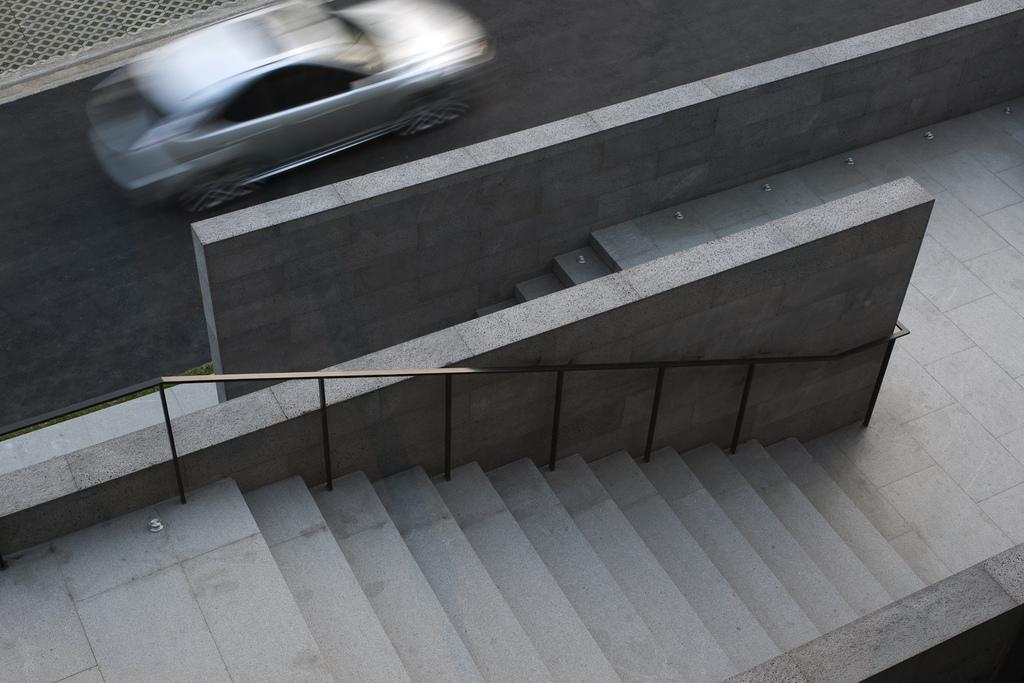What is on the road in the image? There is a vehicle on the road in the image. What can be seen beside the road? There is a wall beside the road. What is present in the image that might be used for support or safety? There is a railing in the image. What architectural feature can be seen in the image? There are steps in the image. What type of seed is growing on the steps in the image? There is no seed or plant growing on the steps in the image. Can you describe the face of the person driving the vehicle in the image? There is no person or face visible in the image; only the vehicle, road, wall, railing, and steps are present. 